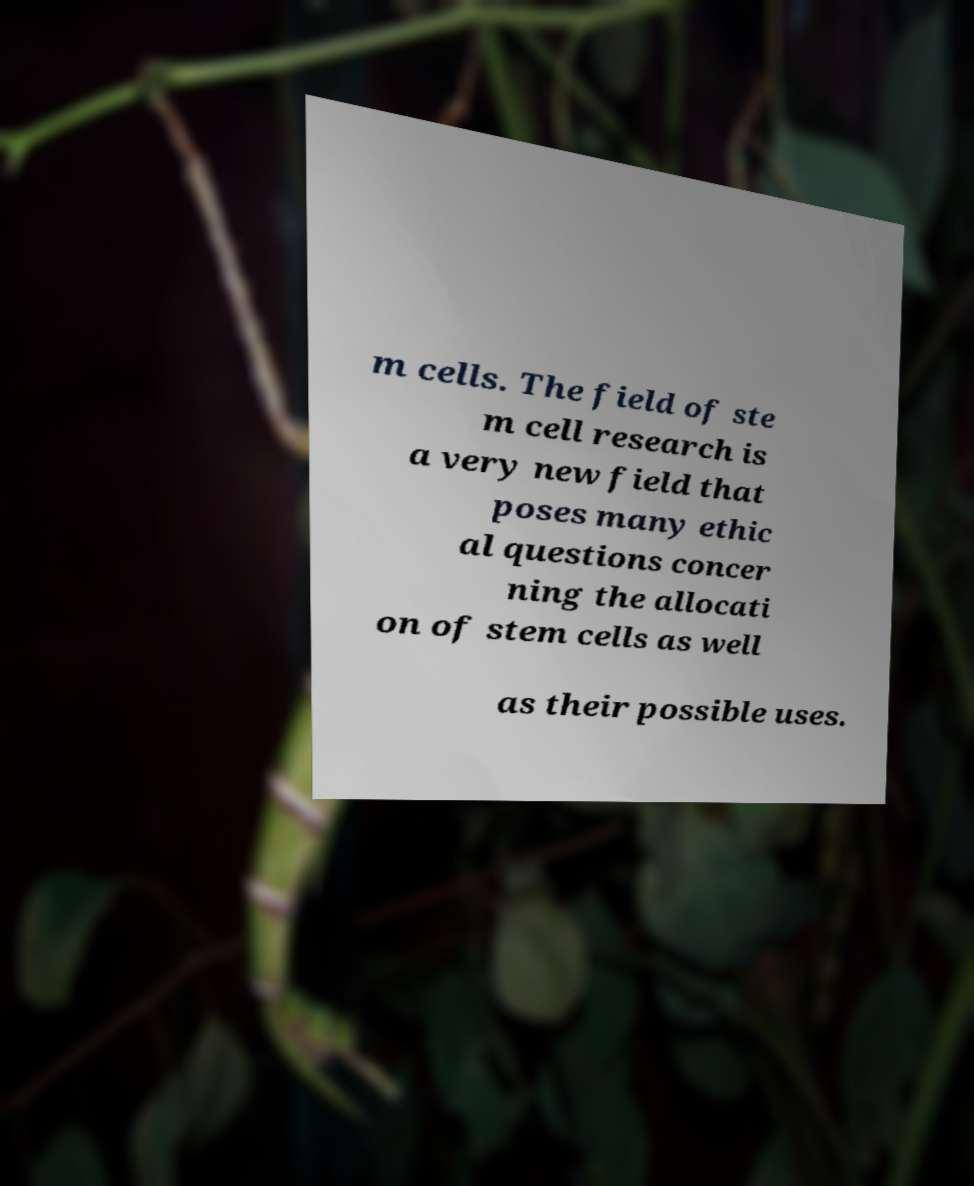Please read and relay the text visible in this image. What does it say? m cells. The field of ste m cell research is a very new field that poses many ethic al questions concer ning the allocati on of stem cells as well as their possible uses. 